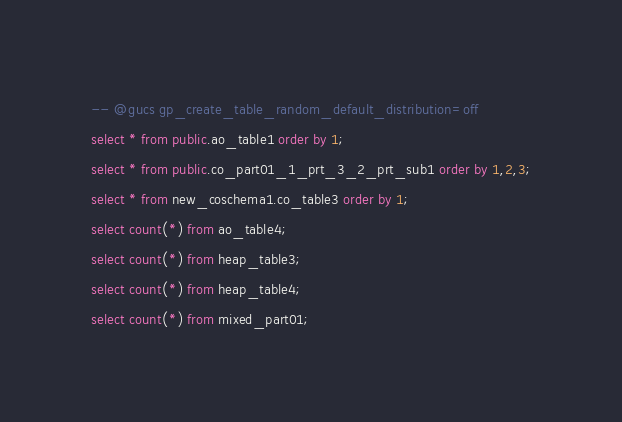<code> <loc_0><loc_0><loc_500><loc_500><_SQL_>-- @gucs gp_create_table_random_default_distribution=off
select * from public.ao_table1 order by 1;
select * from public.co_part01_1_prt_3_2_prt_sub1 order by 1,2,3;
select * from new_coschema1.co_table3 order by 1;
select count(*) from ao_table4;
select count(*) from heap_table3;
select count(*) from heap_table4;
select count(*) from mixed_part01;
</code> 